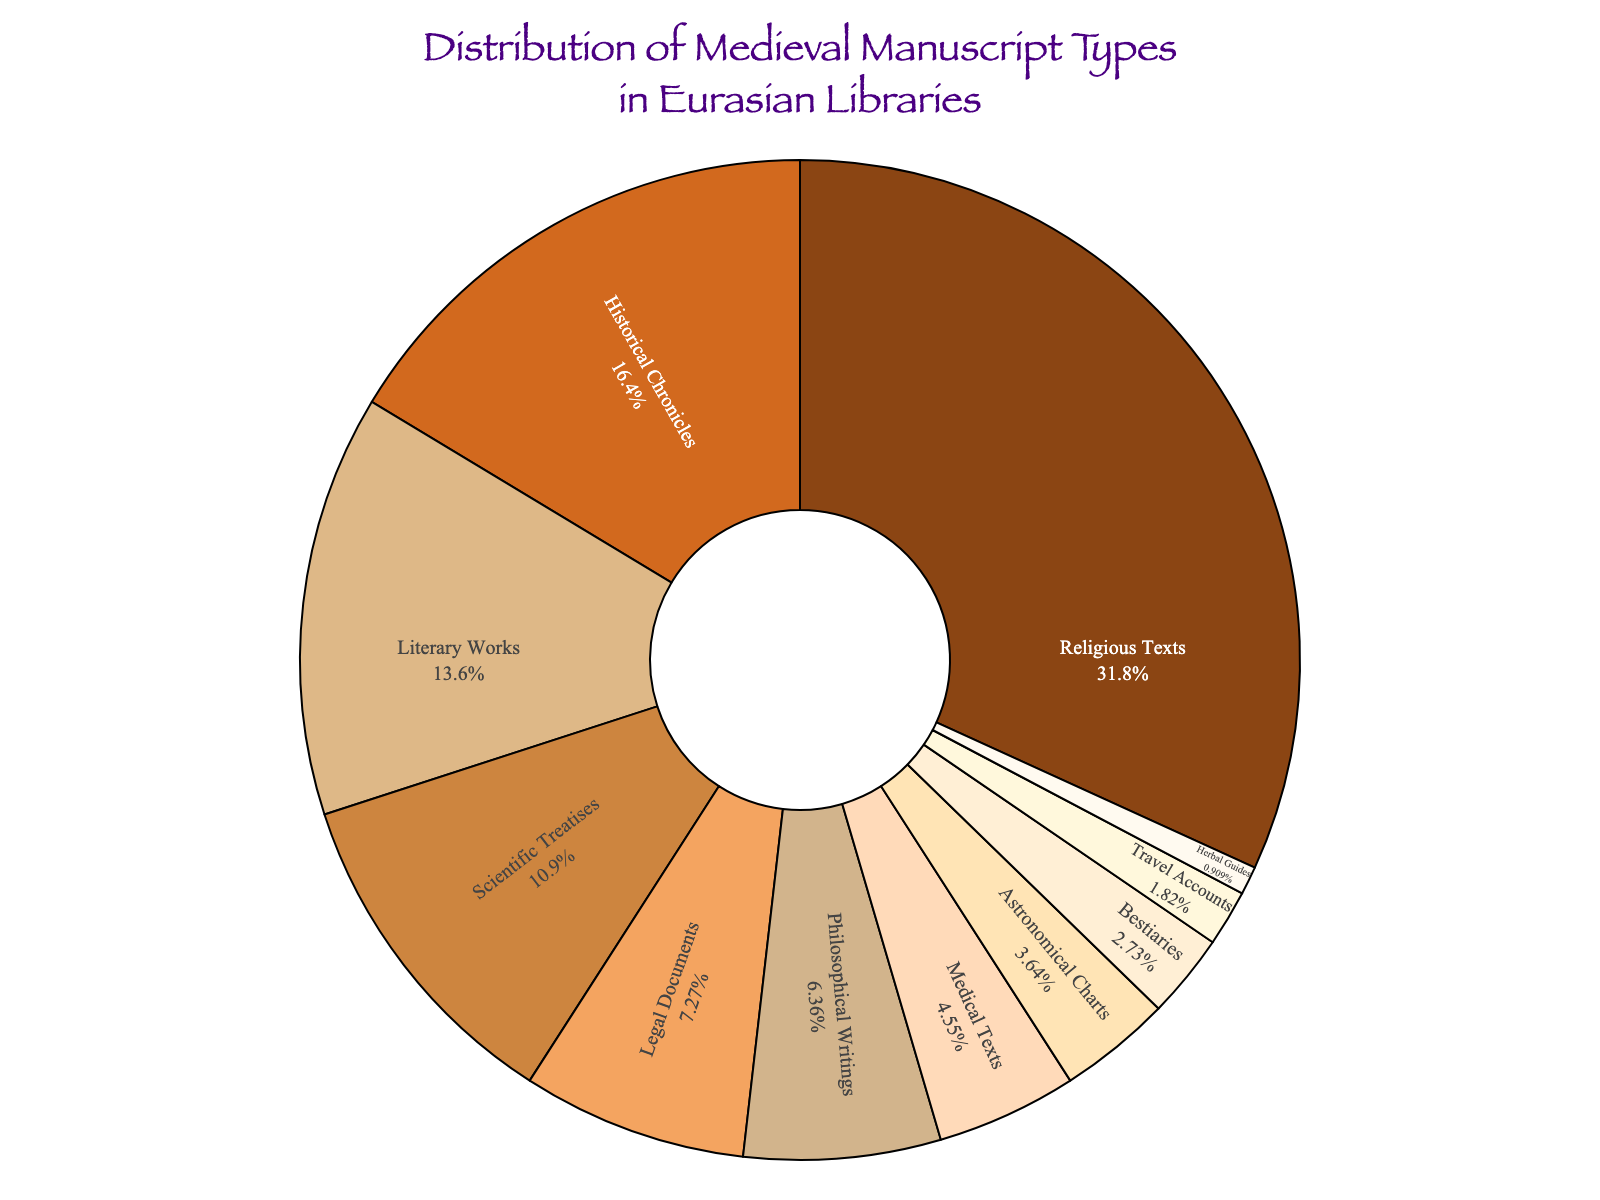Which type of manuscript has the highest percentage? By observing the pie chart, note that the largest segment represents "Religious Texts." The percentage value inside this segment is 35%, which is the highest of all segments.
Answer: Religious Texts What is the combined percentage of Scientific Treatises and Medical Texts? Locate the segments for "Scientific Treatises" (12%) and "Medical Texts" (5%). Add these percentages together: 12% + 5% = 17%.
Answer: 17% Which manuscript type has a smaller percentage: Legal Documents or Philosophical Writings? Compare the percentage values for "Legal Documents" and "Philosophical Writings." Legal Documents have 8%, while Philosophical Writings have 7%. Thus, Philosophical Writings have a smaller percentage.
Answer: Philosophical Writings Are the percentages of Bestiaries and Travel Accounts equal? Check the percentage values inside the segments for Bestiaries (3%) and Travel Accounts (2%). Since 3% is not equal to 2%, they are not equal.
Answer: No How much more prevalent are Literary Works compared to Herbal Guides? Identify the percentages for Literary Works (15%) and Herbal Guides (1%). Subtract the smaller percentage from the larger one: 15% - 1% = 14%.
Answer: 14% What is the second most common type of manuscript? Observe the pie chart and identify the segment with the second-largest percentage after Religious Texts. This segment represents "Historical Chronicles" with 18%.
Answer: Historical Chronicles Which colors represent Legal Documents and Bestiaries in the figure? Refer to the segments for "Legal Documents" and "Bestiaries" and note their colors. Legal Documents are marked with a light brown shade, while Bestiaries are marked with a paler, almost yellow shade.
Answer: Light brown and pale yellow What percentage of the manuscripts are either Literary Works or Historical Chronicles? Locate the segments for Literary Works (15%) and Historical Chronicles (18%). Sum these percentages: 15% + 18% = 33%.
Answer: 33% Is the percentage of Astronomical Charts less than 5%? Identify the percentage for Astronomical Charts in the figure. It is marked as 4%, which is less than 5%.
Answer: Yes 